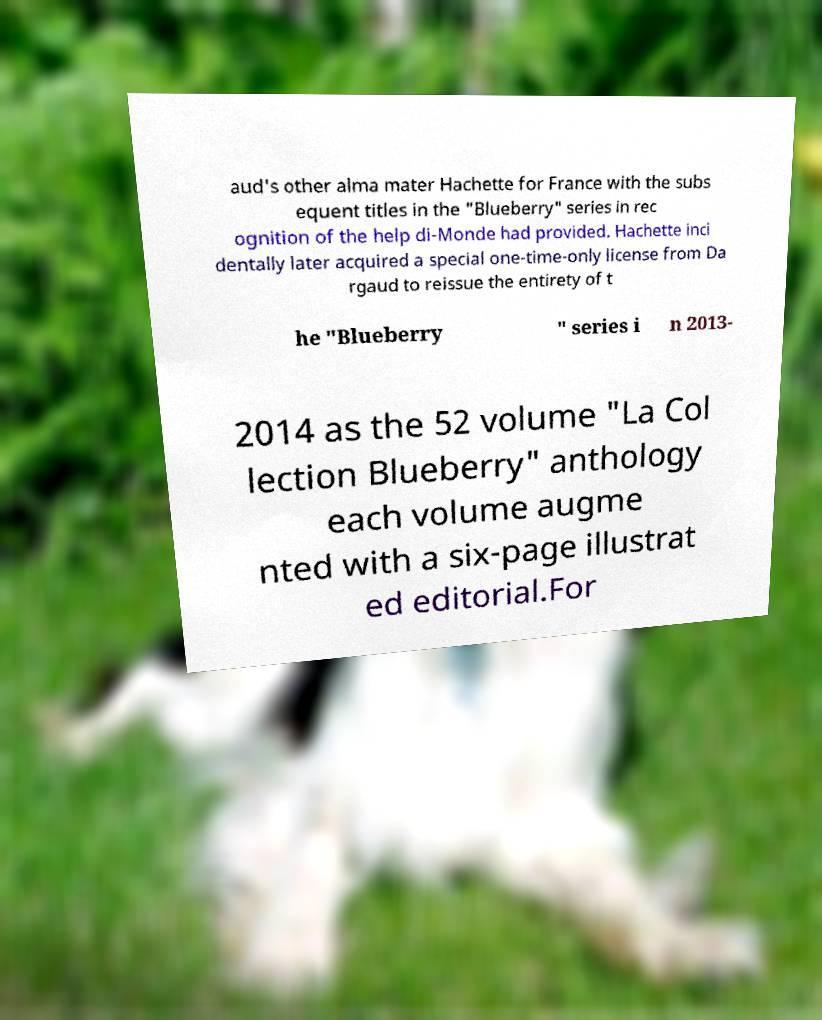Could you assist in decoding the text presented in this image and type it out clearly? aud's other alma mater Hachette for France with the subs equent titles in the "Blueberry" series in rec ognition of the help di-Monde had provided. Hachette inci dentally later acquired a special one-time-only license from Da rgaud to reissue the entirety of t he "Blueberry " series i n 2013- 2014 as the 52 volume "La Col lection Blueberry" anthology each volume augme nted with a six-page illustrat ed editorial.For 